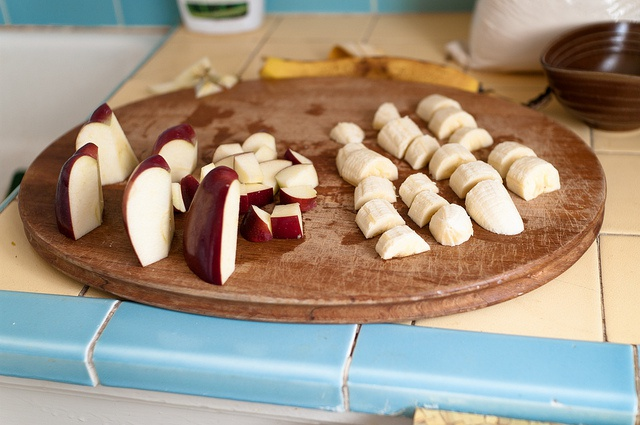Describe the objects in this image and their specific colors. I can see bowl in darkgray, black, maroon, and gray tones, banana in darkgray, ivory, and tan tones, apple in darkgray, maroon, ivory, and brown tones, banana in darkgray, beige, and tan tones, and apple in darkgray, ivory, maroon, tan, and brown tones in this image. 